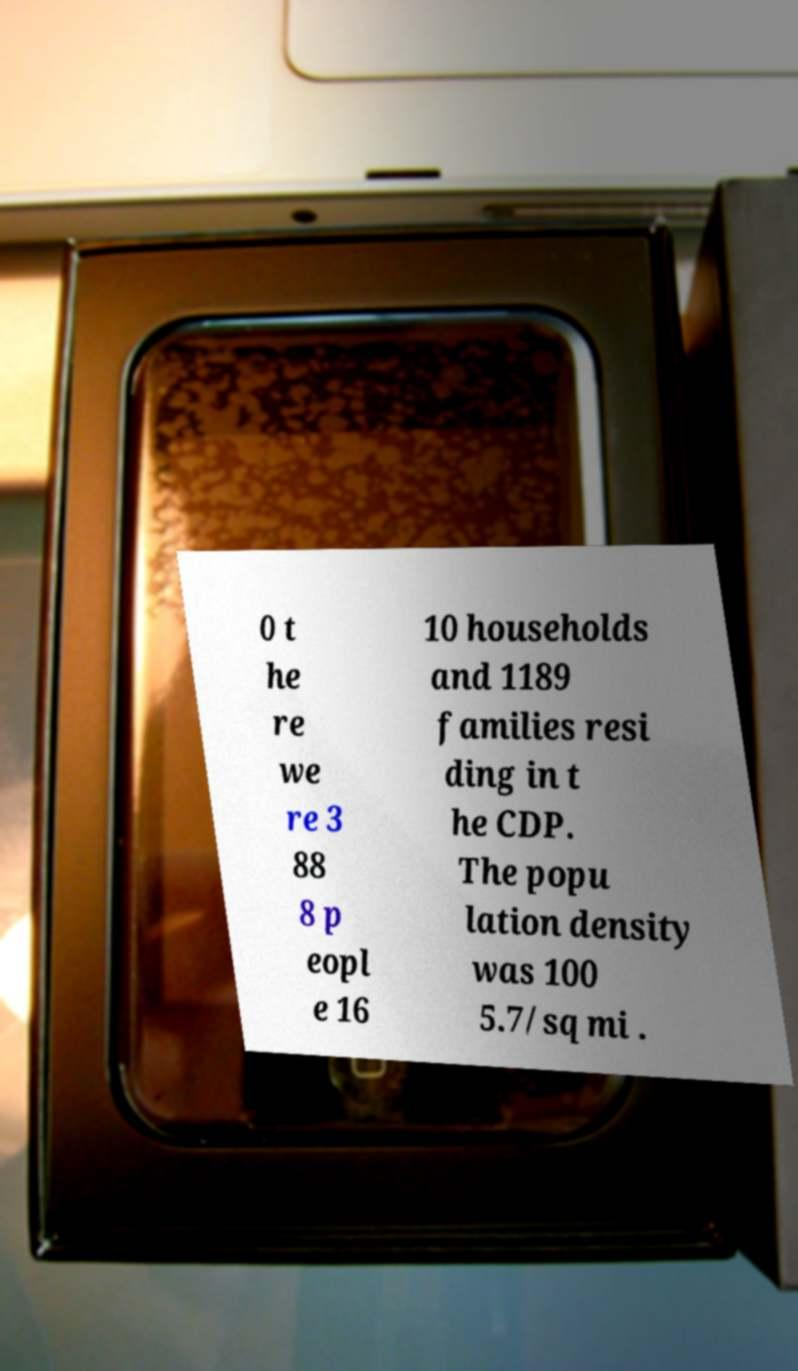Could you assist in decoding the text presented in this image and type it out clearly? 0 t he re we re 3 88 8 p eopl e 16 10 households and 1189 families resi ding in t he CDP. The popu lation density was 100 5.7/sq mi . 